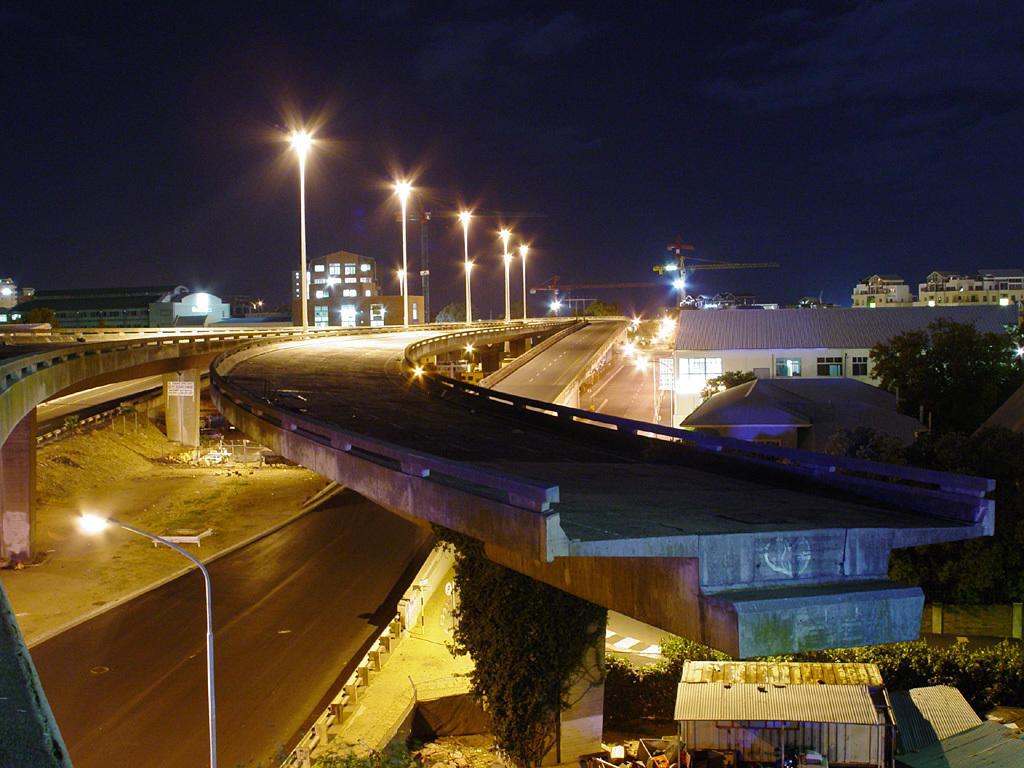Describe this image in one or two sentences. In this image, I can see the buildings, trees and flyovers with street lights. In the background, there is the sky. I can see two tower cranes. 